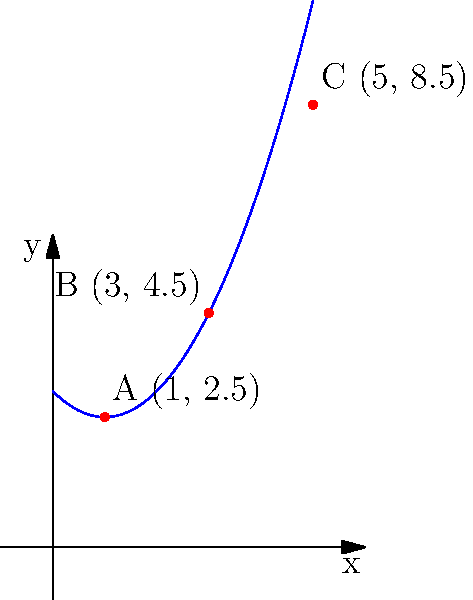In a dramatic scene of your screenplay, Beyoncé is performing on stage with a spotlight following her movements. The spotlight's trajectory is represented by the function $f(x) = 0.5x^2 - x + 3$, where $x$ is the horizontal distance and $f(x)$ is the height, both measured in meters. If the spotlight moves through points A, B, and C as shown in the graph, what is the total vertical distance traveled by the spotlight from point A to point C? To find the total vertical distance traveled by the spotlight from point A to point C, we need to:

1. Identify the y-coordinates (heights) of points A and C:
   Point A: $(1, 2.5)$
   Point C: $(5, 8.5)$

2. Calculate the difference in height:
   $\Delta y = y_C - y_A$
   $\Delta y = 8.5 - 2.5 = 6$ meters

3. Note that this is the net vertical distance, but the question asks for the total vertical distance. Since the spotlight's path is curved, we need to consider the movement from A to B and then from B to C.

4. Calculate the vertical distance from A to B:
   Point B: $(3, 4.5)$
   $\Delta y_{AB} = 4.5 - 2.5 = 2$ meters

5. Calculate the vertical distance from B to C:
   $\Delta y_{BC} = 8.5 - 4.5 = 4$ meters

6. Sum the two vertical distances:
   Total vertical distance $= \Delta y_{AB} + \Delta y_{BC} = 2 + 4 = 6$ meters

This coincides with the net vertical distance, which makes sense as the path is consistently increasing in height.
Answer: 6 meters 